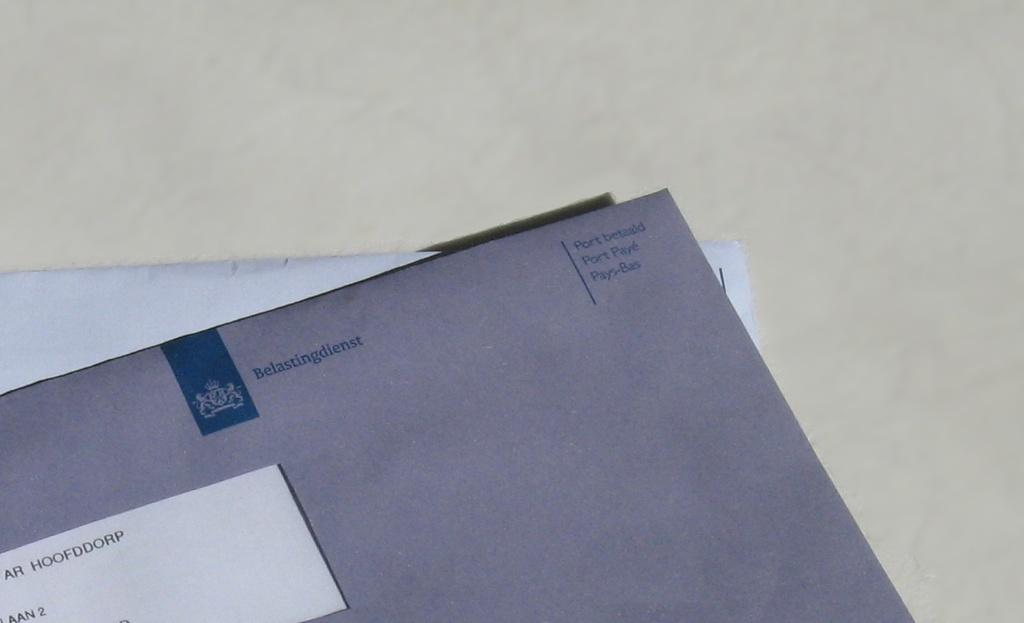<image>
Offer a succinct explanation of the picture presented. An envelope from Belastingdienst on top of a stack 